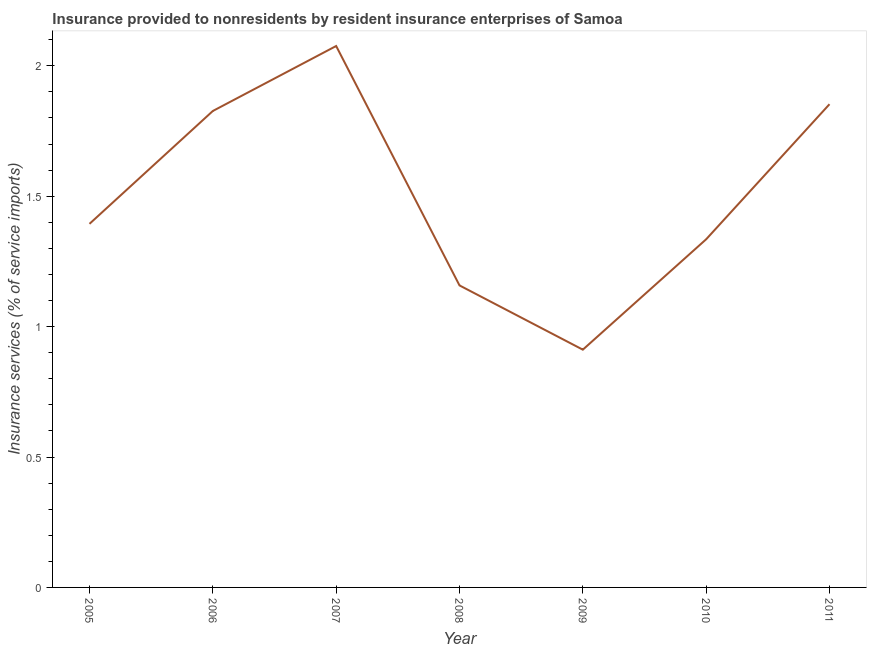What is the insurance and financial services in 2009?
Provide a short and direct response. 0.91. Across all years, what is the maximum insurance and financial services?
Make the answer very short. 2.08. Across all years, what is the minimum insurance and financial services?
Your answer should be very brief. 0.91. What is the sum of the insurance and financial services?
Make the answer very short. 10.55. What is the difference between the insurance and financial services in 2009 and 2011?
Offer a terse response. -0.94. What is the average insurance and financial services per year?
Your answer should be very brief. 1.51. What is the median insurance and financial services?
Ensure brevity in your answer.  1.39. What is the ratio of the insurance and financial services in 2005 to that in 2007?
Make the answer very short. 0.67. What is the difference between the highest and the second highest insurance and financial services?
Ensure brevity in your answer.  0.22. Is the sum of the insurance and financial services in 2005 and 2007 greater than the maximum insurance and financial services across all years?
Provide a short and direct response. Yes. What is the difference between the highest and the lowest insurance and financial services?
Provide a short and direct response. 1.16. Are the values on the major ticks of Y-axis written in scientific E-notation?
Your response must be concise. No. Does the graph contain any zero values?
Give a very brief answer. No. Does the graph contain grids?
Your answer should be compact. No. What is the title of the graph?
Offer a terse response. Insurance provided to nonresidents by resident insurance enterprises of Samoa. What is the label or title of the Y-axis?
Provide a short and direct response. Insurance services (% of service imports). What is the Insurance services (% of service imports) in 2005?
Give a very brief answer. 1.39. What is the Insurance services (% of service imports) in 2006?
Give a very brief answer. 1.83. What is the Insurance services (% of service imports) of 2007?
Provide a succinct answer. 2.08. What is the Insurance services (% of service imports) of 2008?
Ensure brevity in your answer.  1.16. What is the Insurance services (% of service imports) in 2009?
Provide a succinct answer. 0.91. What is the Insurance services (% of service imports) in 2010?
Provide a succinct answer. 1.33. What is the Insurance services (% of service imports) of 2011?
Your response must be concise. 1.85. What is the difference between the Insurance services (% of service imports) in 2005 and 2006?
Provide a short and direct response. -0.43. What is the difference between the Insurance services (% of service imports) in 2005 and 2007?
Provide a succinct answer. -0.68. What is the difference between the Insurance services (% of service imports) in 2005 and 2008?
Provide a succinct answer. 0.24. What is the difference between the Insurance services (% of service imports) in 2005 and 2009?
Your answer should be very brief. 0.48. What is the difference between the Insurance services (% of service imports) in 2005 and 2010?
Keep it short and to the point. 0.06. What is the difference between the Insurance services (% of service imports) in 2005 and 2011?
Provide a short and direct response. -0.46. What is the difference between the Insurance services (% of service imports) in 2006 and 2007?
Your answer should be compact. -0.25. What is the difference between the Insurance services (% of service imports) in 2006 and 2008?
Keep it short and to the point. 0.67. What is the difference between the Insurance services (% of service imports) in 2006 and 2009?
Provide a succinct answer. 0.92. What is the difference between the Insurance services (% of service imports) in 2006 and 2010?
Provide a succinct answer. 0.49. What is the difference between the Insurance services (% of service imports) in 2006 and 2011?
Give a very brief answer. -0.03. What is the difference between the Insurance services (% of service imports) in 2007 and 2008?
Give a very brief answer. 0.92. What is the difference between the Insurance services (% of service imports) in 2007 and 2009?
Offer a very short reply. 1.16. What is the difference between the Insurance services (% of service imports) in 2007 and 2010?
Keep it short and to the point. 0.74. What is the difference between the Insurance services (% of service imports) in 2007 and 2011?
Make the answer very short. 0.22. What is the difference between the Insurance services (% of service imports) in 2008 and 2009?
Keep it short and to the point. 0.25. What is the difference between the Insurance services (% of service imports) in 2008 and 2010?
Give a very brief answer. -0.18. What is the difference between the Insurance services (% of service imports) in 2008 and 2011?
Your response must be concise. -0.69. What is the difference between the Insurance services (% of service imports) in 2009 and 2010?
Your answer should be compact. -0.42. What is the difference between the Insurance services (% of service imports) in 2009 and 2011?
Your answer should be very brief. -0.94. What is the difference between the Insurance services (% of service imports) in 2010 and 2011?
Keep it short and to the point. -0.52. What is the ratio of the Insurance services (% of service imports) in 2005 to that in 2006?
Offer a terse response. 0.76. What is the ratio of the Insurance services (% of service imports) in 2005 to that in 2007?
Give a very brief answer. 0.67. What is the ratio of the Insurance services (% of service imports) in 2005 to that in 2008?
Make the answer very short. 1.2. What is the ratio of the Insurance services (% of service imports) in 2005 to that in 2009?
Make the answer very short. 1.53. What is the ratio of the Insurance services (% of service imports) in 2005 to that in 2010?
Your response must be concise. 1.04. What is the ratio of the Insurance services (% of service imports) in 2005 to that in 2011?
Your response must be concise. 0.75. What is the ratio of the Insurance services (% of service imports) in 2006 to that in 2008?
Make the answer very short. 1.58. What is the ratio of the Insurance services (% of service imports) in 2006 to that in 2009?
Give a very brief answer. 2. What is the ratio of the Insurance services (% of service imports) in 2006 to that in 2010?
Keep it short and to the point. 1.37. What is the ratio of the Insurance services (% of service imports) in 2006 to that in 2011?
Your response must be concise. 0.99. What is the ratio of the Insurance services (% of service imports) in 2007 to that in 2008?
Offer a very short reply. 1.79. What is the ratio of the Insurance services (% of service imports) in 2007 to that in 2009?
Provide a succinct answer. 2.28. What is the ratio of the Insurance services (% of service imports) in 2007 to that in 2010?
Make the answer very short. 1.55. What is the ratio of the Insurance services (% of service imports) in 2007 to that in 2011?
Provide a succinct answer. 1.12. What is the ratio of the Insurance services (% of service imports) in 2008 to that in 2009?
Give a very brief answer. 1.27. What is the ratio of the Insurance services (% of service imports) in 2008 to that in 2010?
Provide a succinct answer. 0.87. What is the ratio of the Insurance services (% of service imports) in 2009 to that in 2010?
Give a very brief answer. 0.68. What is the ratio of the Insurance services (% of service imports) in 2009 to that in 2011?
Make the answer very short. 0.49. What is the ratio of the Insurance services (% of service imports) in 2010 to that in 2011?
Give a very brief answer. 0.72. 